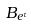Convert formula to latex. <formula><loc_0><loc_0><loc_500><loc_500>B _ { e ^ { \tau } }</formula> 